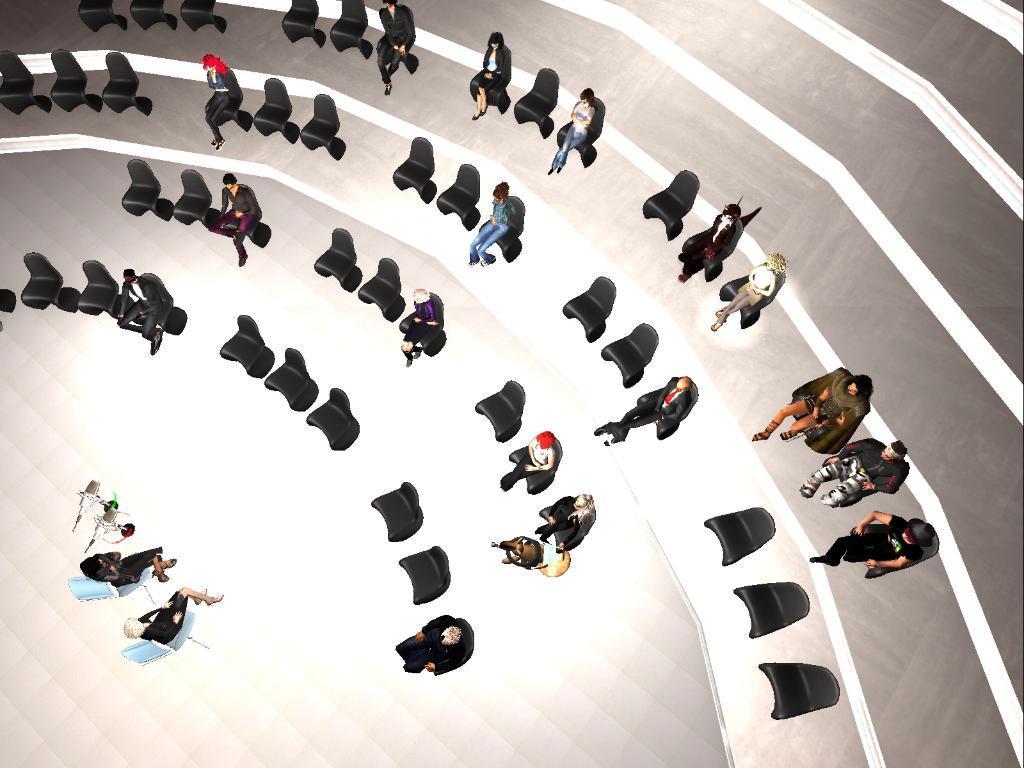In one or two sentences, can you explain what this image depicts? This is an animation picture. In this image there are group of people sitting on the chairs. There are many chairs. At the bottom there are microphones. 